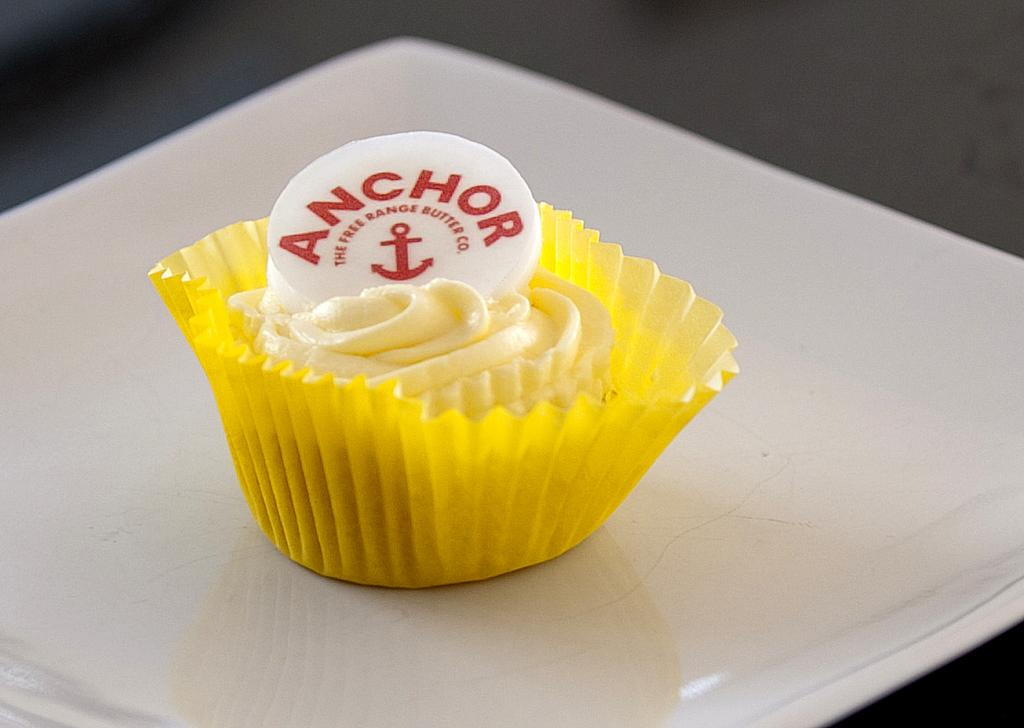What is on the plate in the image? There is a paper cup on the plate in the image. What is inside the paper cup? The paper cup contains butter. Is there any branding or identification on the butter? Yes, there is a logo on the butter. How many boats are visible in the image? There are no boats present in the image. What type of lumber is being used to make the butter in the image? There is no lumber involved in the making of butter, and the image does not show any lumber. 